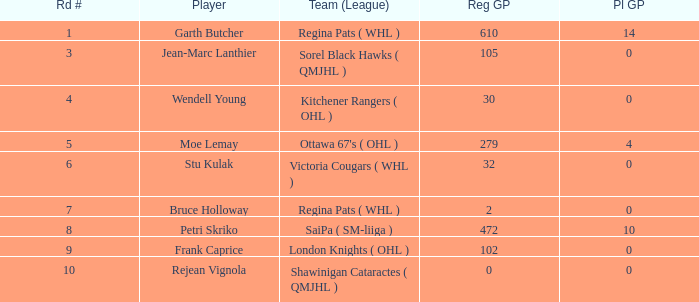What is the mean road number when Moe Lemay is the player? 5.0. 